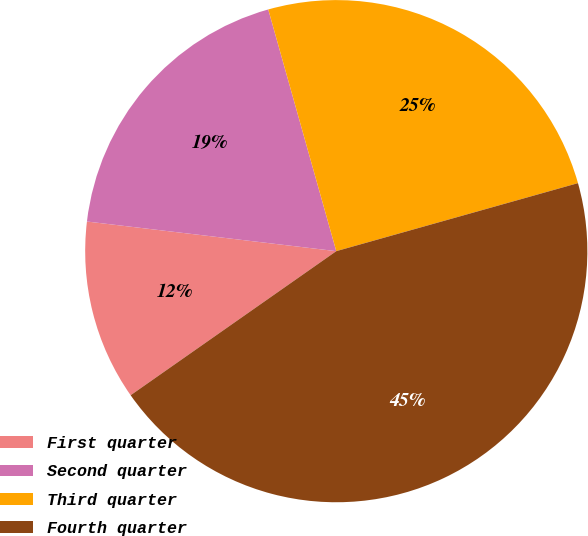Convert chart. <chart><loc_0><loc_0><loc_500><loc_500><pie_chart><fcel>First quarter<fcel>Second quarter<fcel>Third quarter<fcel>Fourth quarter<nl><fcel>11.61%<fcel>18.75%<fcel>25.0%<fcel>44.64%<nl></chart> 